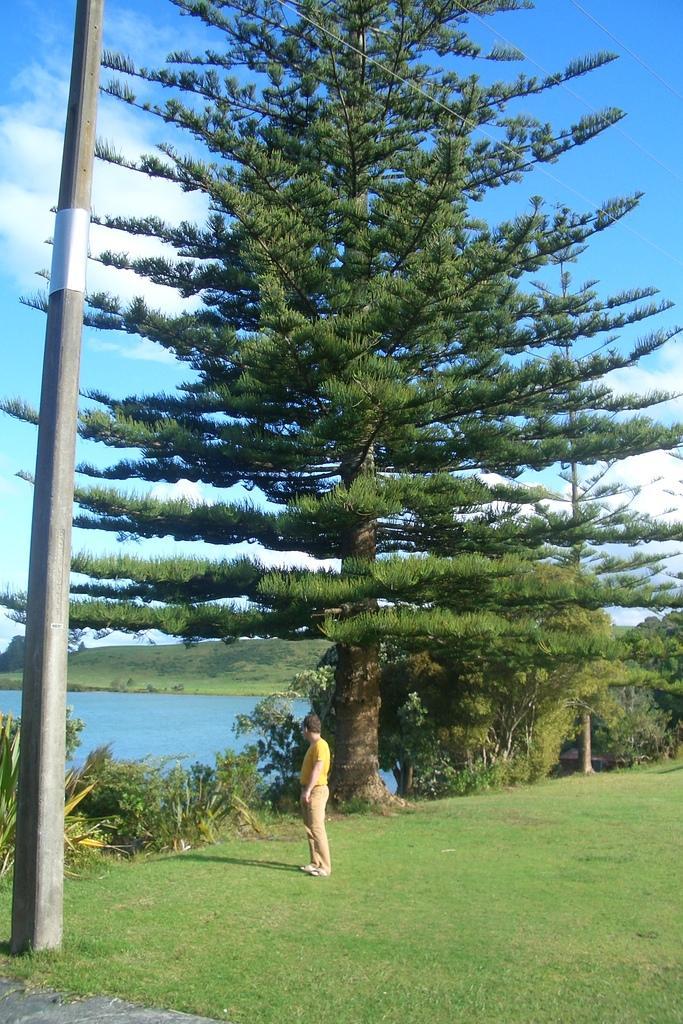Please provide a concise description of this image. There is a person standing on a greenery ground and there are trees behind him and there are water and a pole in the left corner. 